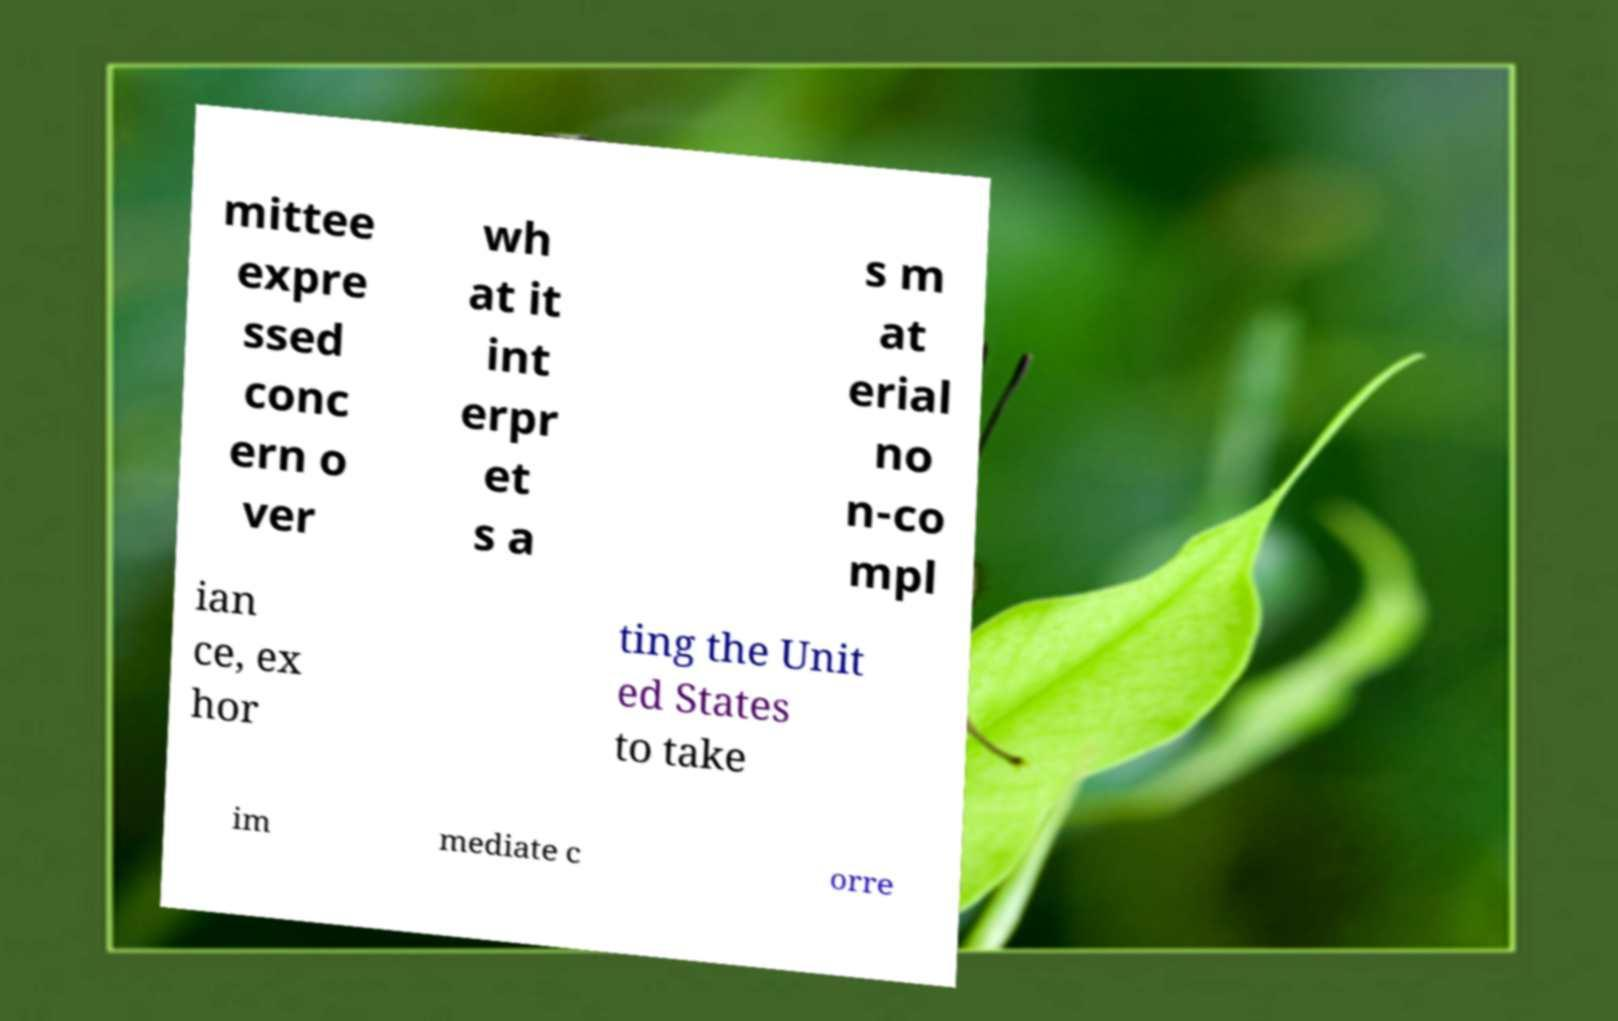Could you assist in decoding the text presented in this image and type it out clearly? mittee expre ssed conc ern o ver wh at it int erpr et s a s m at erial no n-co mpl ian ce, ex hor ting the Unit ed States to take im mediate c orre 